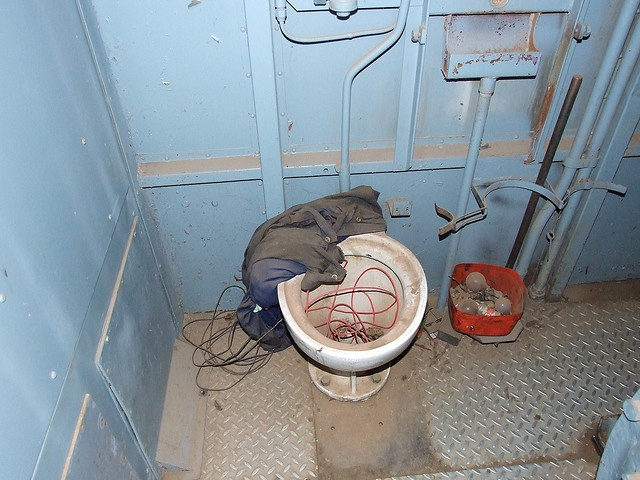Describe the objects in this image and their specific colors. I can see a toilet in lightblue, tan, lightgray, and darkgray tones in this image. 